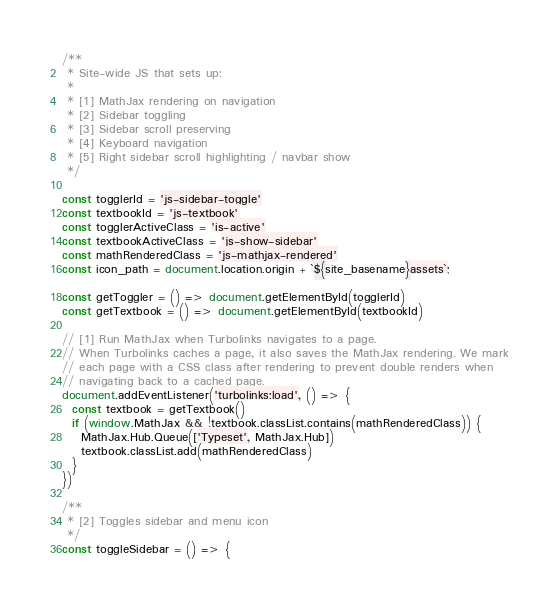Convert code to text. <code><loc_0><loc_0><loc_500><loc_500><_JavaScript_>/**
 * Site-wide JS that sets up:
 *
 * [1] MathJax rendering on navigation
 * [2] Sidebar toggling
 * [3] Sidebar scroll preserving
 * [4] Keyboard navigation
 * [5] Right sidebar scroll highlighting / navbar show
 */

const togglerId = 'js-sidebar-toggle'
const textbookId = 'js-textbook'
const togglerActiveClass = 'is-active'
const textbookActiveClass = 'js-show-sidebar'
const mathRenderedClass = 'js-mathjax-rendered'
const icon_path = document.location.origin + `${site_basename}assets`;

const getToggler = () => document.getElementById(togglerId)
const getTextbook = () => document.getElementById(textbookId)

// [1] Run MathJax when Turbolinks navigates to a page.
// When Turbolinks caches a page, it also saves the MathJax rendering. We mark
// each page with a CSS class after rendering to prevent double renders when
// navigating back to a cached page.
document.addEventListener('turbolinks:load', () => {
  const textbook = getTextbook()
  if (window.MathJax && !textbook.classList.contains(mathRenderedClass)) {
    MathJax.Hub.Queue(['Typeset', MathJax.Hub])
    textbook.classList.add(mathRenderedClass)
  }
})

/**
 * [2] Toggles sidebar and menu icon
 */
const toggleSidebar = () => {</code> 